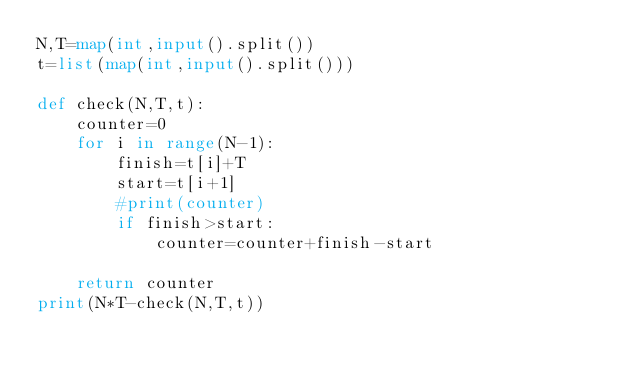<code> <loc_0><loc_0><loc_500><loc_500><_Python_>N,T=map(int,input().split())
t=list(map(int,input().split()))

def check(N,T,t):
    counter=0
    for i in range(N-1):
        finish=t[i]+T
        start=t[i+1]
        #print(counter)        
        if finish>start:
            counter=counter+finish-start
                 
    return counter
print(N*T-check(N,T,t))</code> 